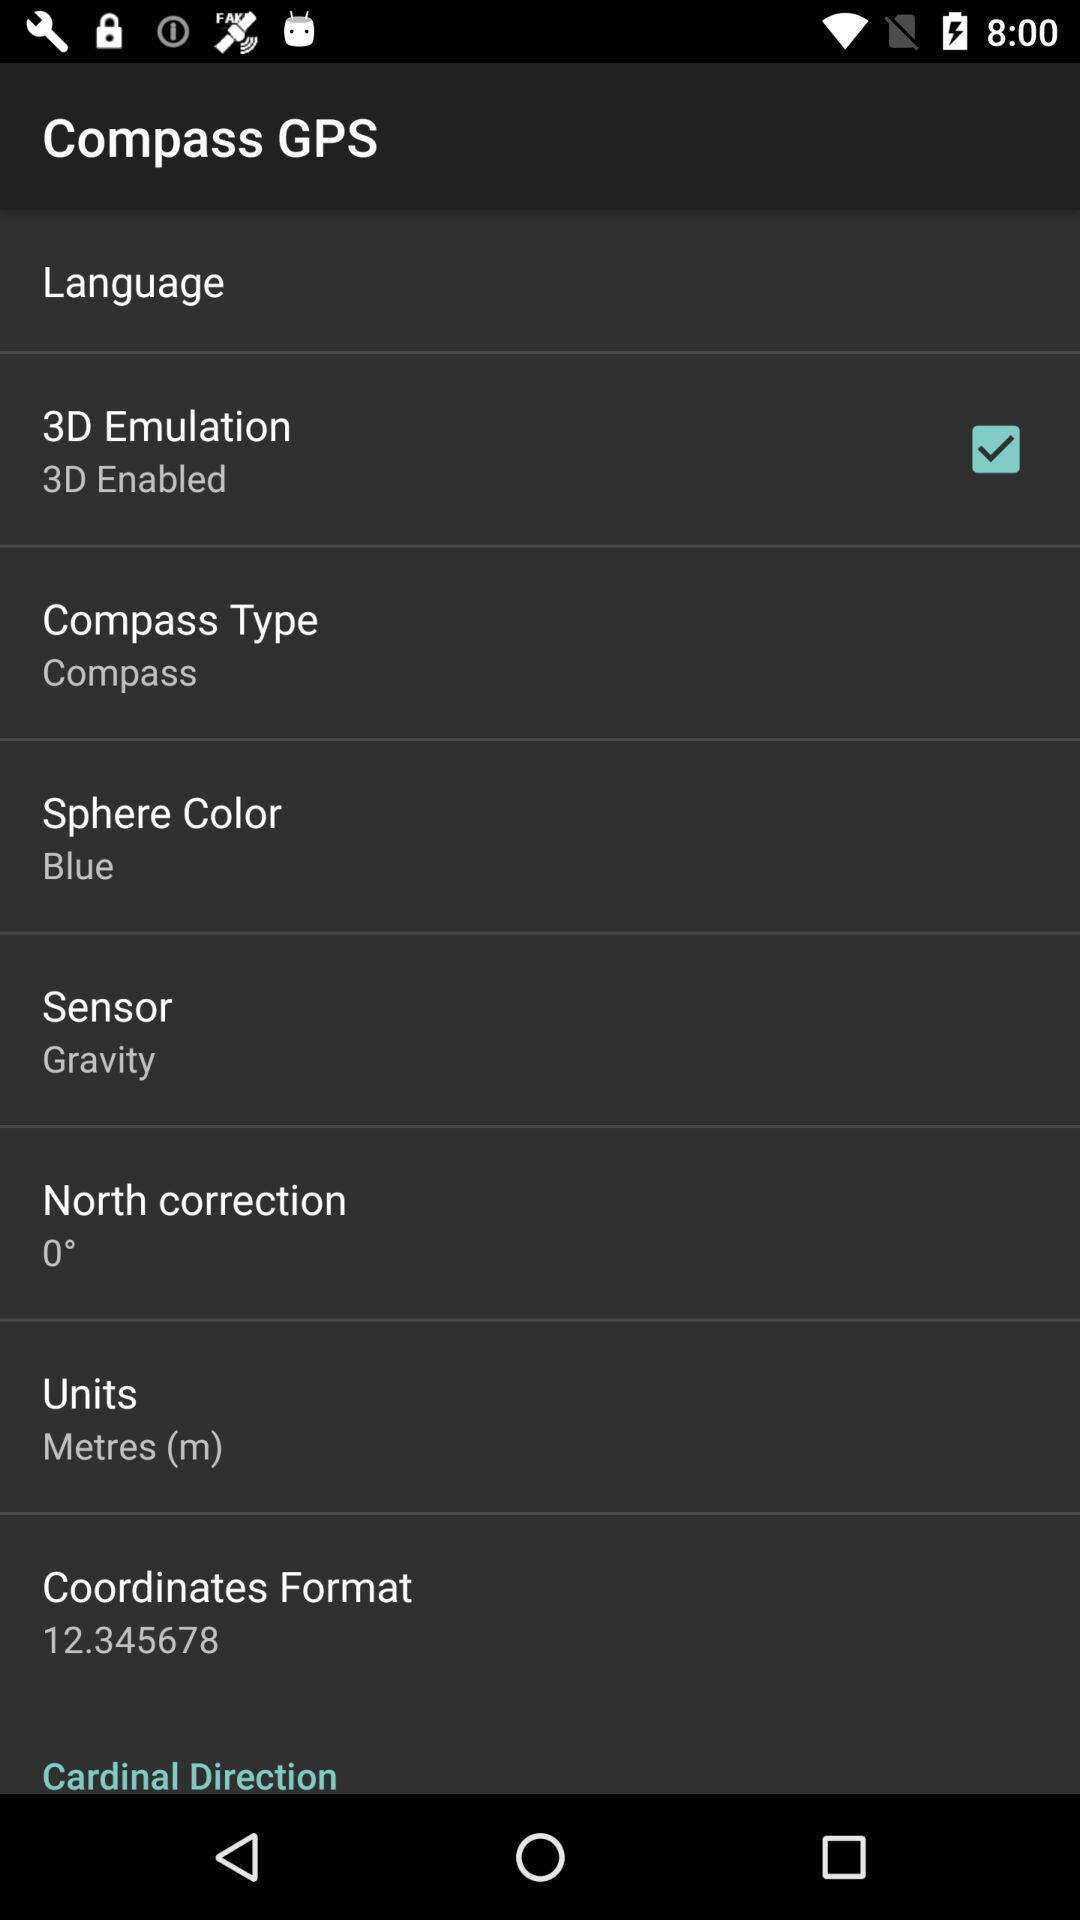What is the latitude? The latitude is 37.738099. 